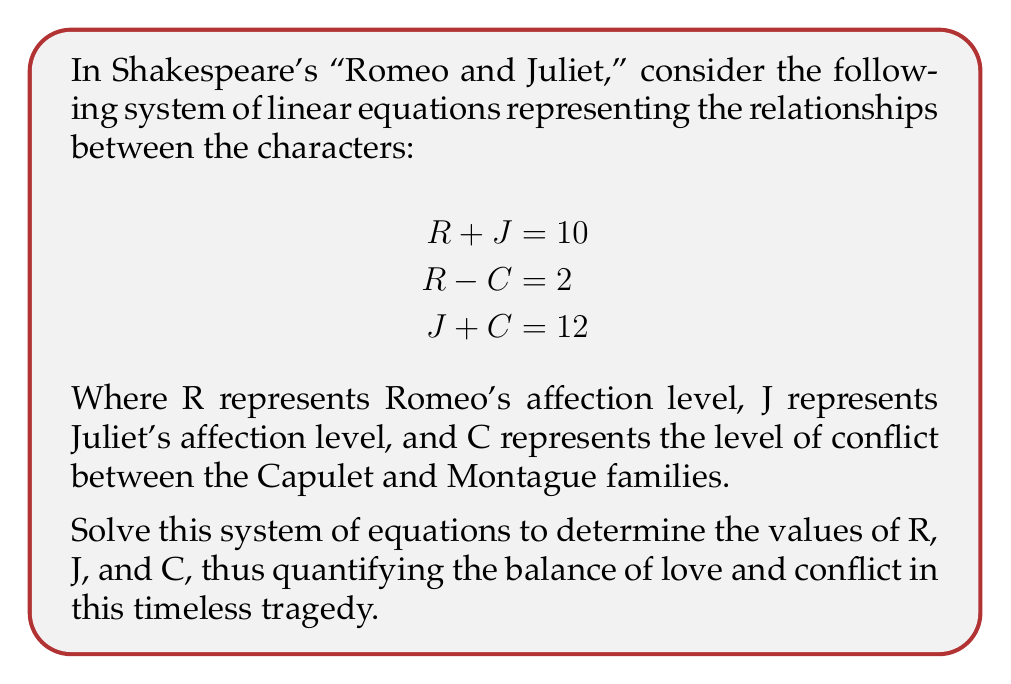Teach me how to tackle this problem. To solve this system of linear equations, we will use the substitution method, a classic approach befitting our appreciation for traditional literary analysis:

1) From the first equation, we can express J in terms of R:
   $$J = 10 - R$$

2) Substitute this expression for J into the third equation:
   $$(10 - R) + C = 12$$
   $$10 - R + C = 12$$
   $$-R + C = 2$$

3) Now we have two equations with R and C:
   $$R - C = 2$$
   $$-R + C = 2$$

4) Add these equations to eliminate R:
   $$(R - C) + (-R + C) = 2 + 2$$
   $$0 = 4$$
   $$2C = 4$$
   $$C = 2$$

5) Substitute C = 2 into $R - C = 2$:
   $$R - 2 = 2$$
   $$R = 4$$

6) Finally, substitute R = 4 into $R + J = 10$:
   $$4 + J = 10$$
   $$J = 6$$

Thus, we have solved for all three variables: R = 4, J = 6, and C = 2.
Answer: R = 4, J = 6, C = 2 